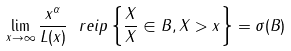<formula> <loc_0><loc_0><loc_500><loc_500>\lim _ { x \rightarrow \infty } \frac { x ^ { \alpha } } { L ( x ) } \ r e i p \left \{ \frac { X } { \| X \| } \in B , \| X \| > x \right \} = \sigma ( B )</formula> 